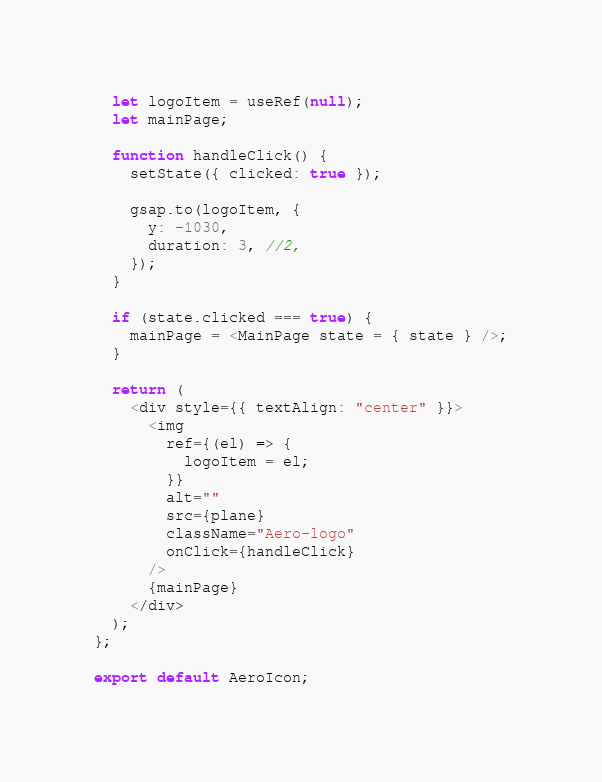<code> <loc_0><loc_0><loc_500><loc_500><_JavaScript_>
  let logoItem = useRef(null);
  let mainPage;

  function handleClick() {
    setState({ clicked: true });

    gsap.to(logoItem, {
      y: -1030,
      duration: 3, //2,
    });
  }

  if (state.clicked === true) {
    mainPage = <MainPage state = { state } />;
  }

  return (
    <div style={{ textAlign: "center" }}>
      <img
        ref={(el) => {
          logoItem = el;
        }}
        alt=""
        src={plane}
        className="Aero-logo"
        onClick={handleClick}
      />
      {mainPage}
    </div>
  );
};

export default AeroIcon;
</code> 